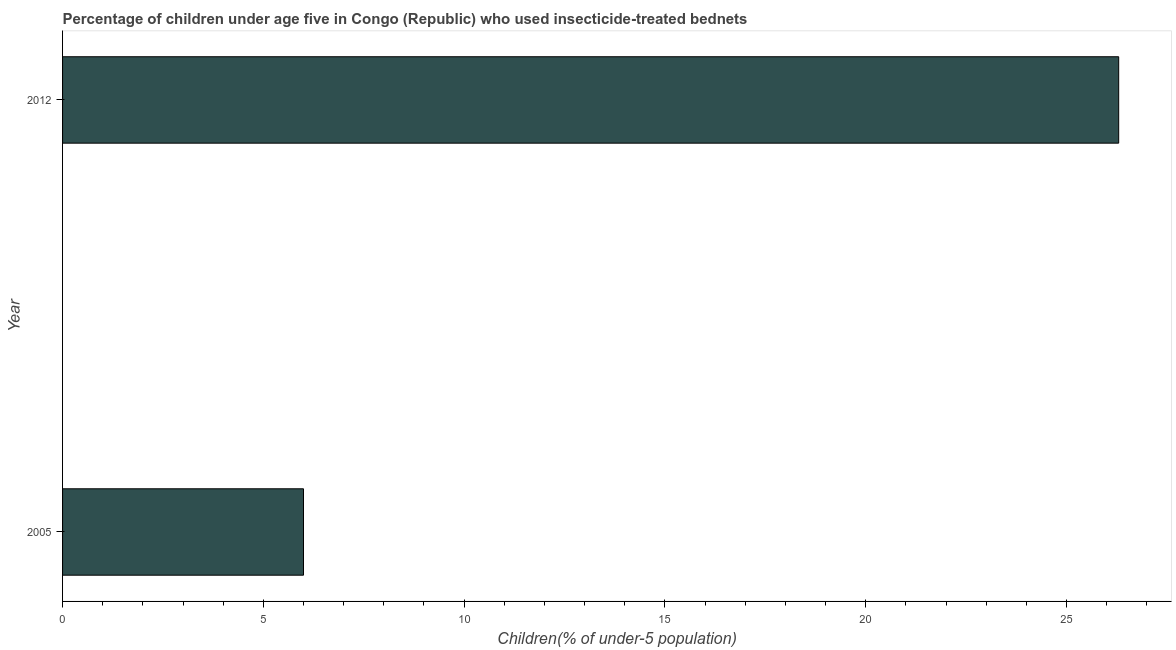Does the graph contain grids?
Your answer should be very brief. No. What is the title of the graph?
Provide a succinct answer. Percentage of children under age five in Congo (Republic) who used insecticide-treated bednets. What is the label or title of the X-axis?
Give a very brief answer. Children(% of under-5 population). What is the percentage of children who use of insecticide-treated bed nets in 2012?
Provide a succinct answer. 26.3. Across all years, what is the maximum percentage of children who use of insecticide-treated bed nets?
Make the answer very short. 26.3. In which year was the percentage of children who use of insecticide-treated bed nets maximum?
Ensure brevity in your answer.  2012. In which year was the percentage of children who use of insecticide-treated bed nets minimum?
Your answer should be compact. 2005. What is the sum of the percentage of children who use of insecticide-treated bed nets?
Keep it short and to the point. 32.3. What is the difference between the percentage of children who use of insecticide-treated bed nets in 2005 and 2012?
Provide a short and direct response. -20.3. What is the average percentage of children who use of insecticide-treated bed nets per year?
Give a very brief answer. 16.15. What is the median percentage of children who use of insecticide-treated bed nets?
Provide a short and direct response. 16.15. What is the ratio of the percentage of children who use of insecticide-treated bed nets in 2005 to that in 2012?
Keep it short and to the point. 0.23. In how many years, is the percentage of children who use of insecticide-treated bed nets greater than the average percentage of children who use of insecticide-treated bed nets taken over all years?
Make the answer very short. 1. Are all the bars in the graph horizontal?
Keep it short and to the point. Yes. What is the Children(% of under-5 population) in 2012?
Give a very brief answer. 26.3. What is the difference between the Children(% of under-5 population) in 2005 and 2012?
Give a very brief answer. -20.3. What is the ratio of the Children(% of under-5 population) in 2005 to that in 2012?
Make the answer very short. 0.23. 